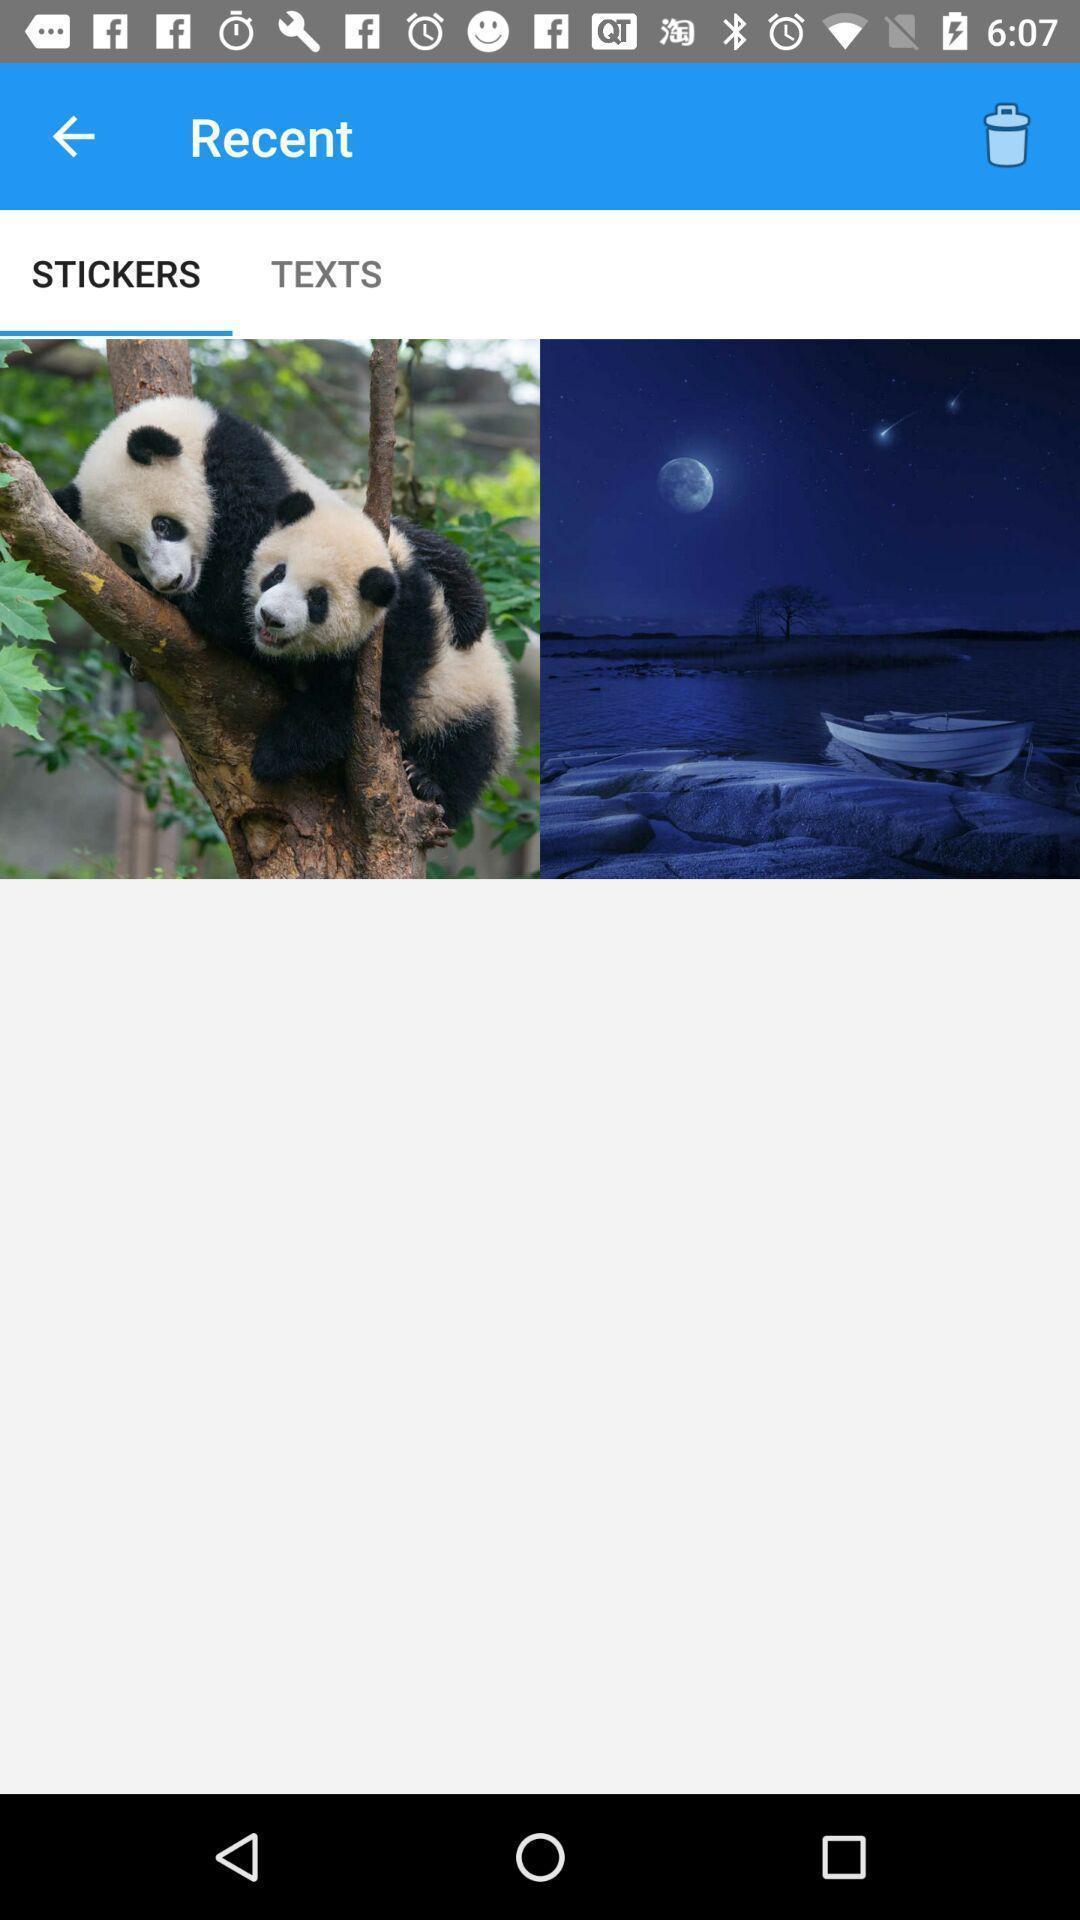Please provide a description for this image. Stickers page on a social app. 